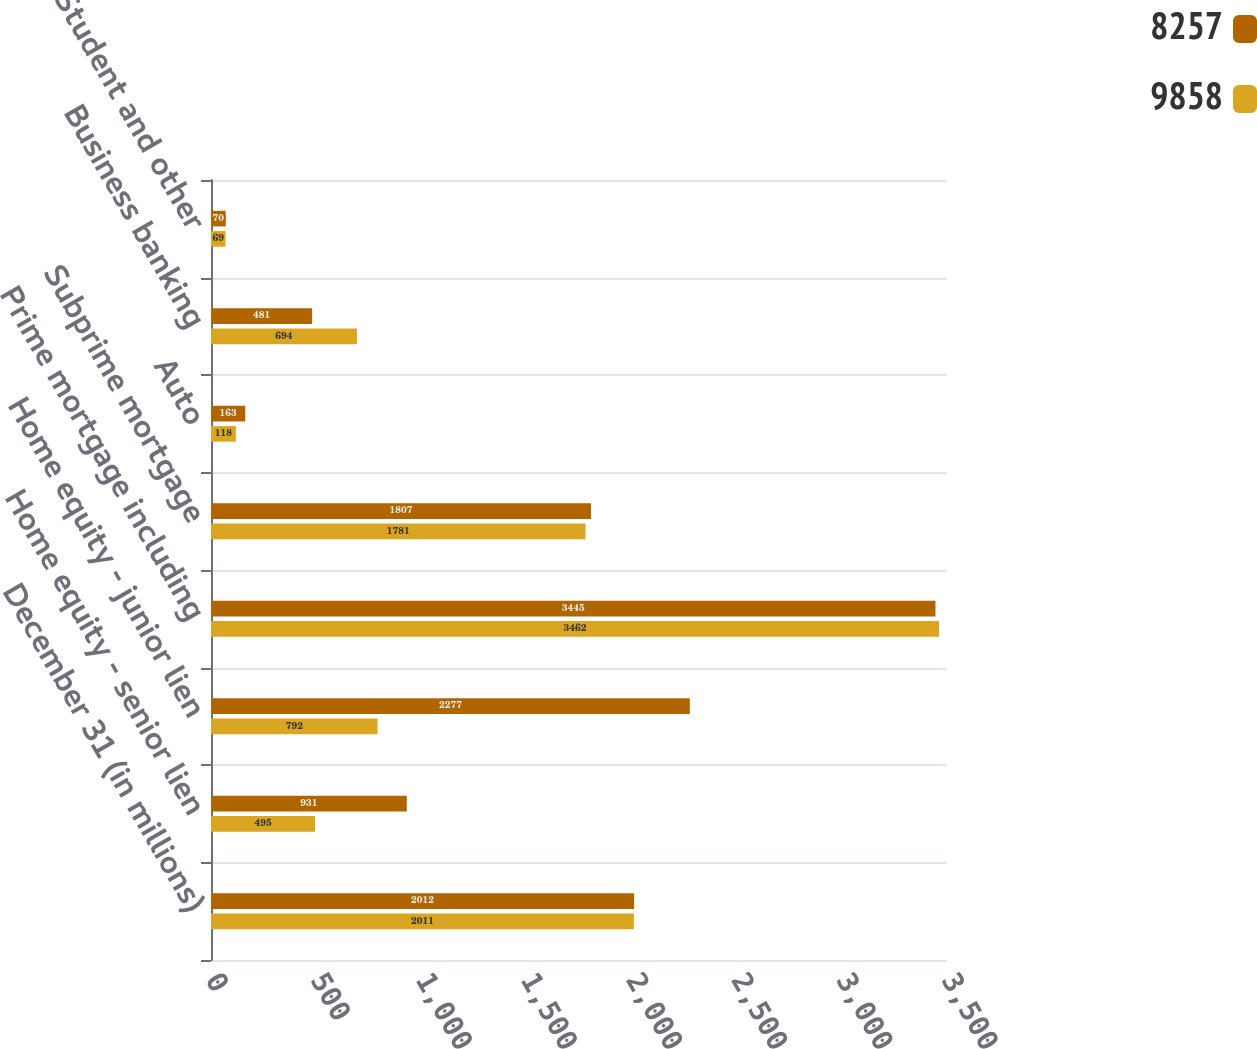<chart> <loc_0><loc_0><loc_500><loc_500><stacked_bar_chart><ecel><fcel>December 31 (in millions)<fcel>Home equity - senior lien<fcel>Home equity - junior lien<fcel>Prime mortgage including<fcel>Subprime mortgage<fcel>Auto<fcel>Business banking<fcel>Student and other<nl><fcel>8257<fcel>2012<fcel>931<fcel>2277<fcel>3445<fcel>1807<fcel>163<fcel>481<fcel>70<nl><fcel>9858<fcel>2011<fcel>495<fcel>792<fcel>3462<fcel>1781<fcel>118<fcel>694<fcel>69<nl></chart> 